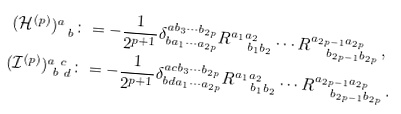<formula> <loc_0><loc_0><loc_500><loc_500>( \mathcal { H } ^ { ( p ) } ) ^ { a } _ { \ b } & \colon = - \frac { 1 } { 2 ^ { p + 1 } } \delta ^ { a b _ { 3 } \cdots b _ { 2 p } } _ { b a _ { 1 } \cdots a _ { 2 p } } R ^ { a _ { 1 } a _ { 2 } } _ { \quad b _ { 1 } b _ { 2 } } \cdots R ^ { a _ { 2 p - 1 } a _ { 2 p } } _ { \quad b _ { 2 p - 1 } b _ { 2 p } } \, , \\ ( \mathcal { I } ^ { ( p ) } ) ^ { a \ c } _ { \ b \ d } & \colon = - \frac { 1 } { 2 ^ { p + 1 } } \delta ^ { a c b _ { 3 } \cdots b _ { 2 p } } _ { b d a _ { 1 } \cdots a _ { 2 p } } R ^ { a _ { 1 } a _ { 2 } } _ { \quad b _ { 1 } b _ { 2 } } \cdots R ^ { a _ { 2 p - 1 } a _ { 2 p } } _ { \quad b _ { 2 p - 1 } b _ { 2 p } } \, .</formula> 